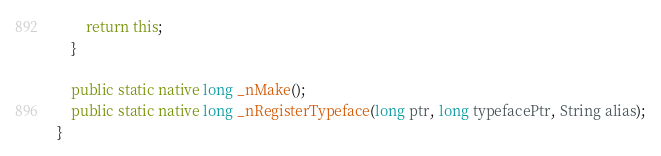Convert code to text. <code><loc_0><loc_0><loc_500><loc_500><_Java_>        return this;
    }

    public static native long _nMake();
    public static native long _nRegisterTypeface(long ptr, long typefacePtr, String alias);
}</code> 